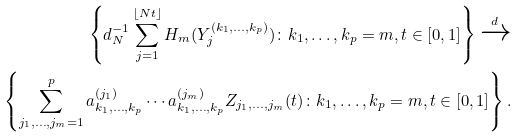Convert formula to latex. <formula><loc_0><loc_0><loc_500><loc_500>\left \{ d _ { N } ^ { - 1 } \sum _ { j = 1 } ^ { \lfloor N t \rfloor } H _ { m } ( Y _ { j } ^ { ( k _ { 1 } , \dots , k _ { p } ) } ) \colon k _ { 1 } , \dots , k _ { p } = m , t \in [ 0 , 1 ] \right \} \xrightarrow { d } \\ \left \{ \sum _ { j _ { 1 } , \dots , j _ { m } = 1 } ^ { p } a _ { k _ { 1 } , \dots , k _ { p } } ^ { ( j _ { 1 } ) } \cdots a _ { k _ { 1 } , \dots , k _ { p } } ^ { ( j _ { m } ) } Z _ { j _ { 1 } , \dots , j _ { m } } ( t ) \colon k _ { 1 } , \dots , k _ { p } = m , t \in [ 0 , 1 ] \right \} .</formula> 